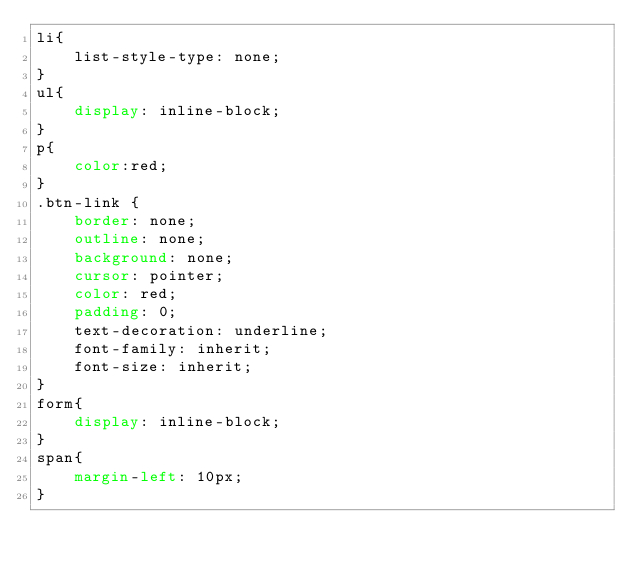<code> <loc_0><loc_0><loc_500><loc_500><_CSS_>li{
    list-style-type: none;
}
ul{
    display: inline-block;
}
p{
    color:red;
}
.btn-link {
    border: none;
    outline: none;
    background: none;
    cursor: pointer;
    color: red;
    padding: 0;
    text-decoration: underline;
    font-family: inherit;
    font-size: inherit;
}
form{
    display: inline-block;
}
span{
    margin-left: 10px;
}
</code> 